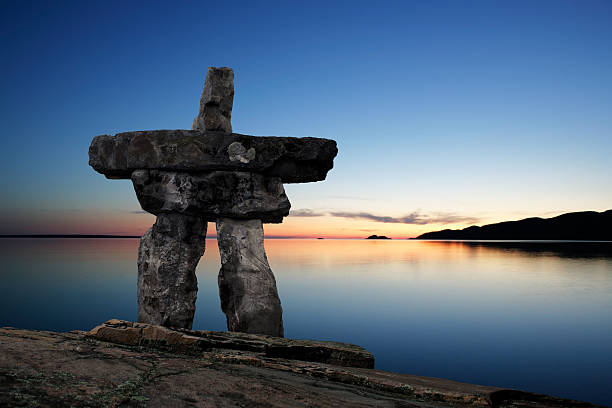What do you see happening in this image? The image showcases a tranquil sunset scene featuring a traditional stone landmark called an Inukshuk, which is constructed by the Inuit people. Situated on a rocky shoreline, the Inukshuk is made of large, flat stones skillfully arranged to resemble a human figure. The deep blue sky, graded with shades of orange and pink near the horizon, creates a vibrant backdrop. Calm waters in the foreground mirror the sky's colors, amplifying the peacefulness of the scene. This serene setting, captured from the side of the Inukshuk, directs the viewer's gaze towards the distant horizon, evoking a sense of depth and expansiveness. The image beautifully captures elements of Inuit culture alongside the natural splendor of the landscape where these landmarks are commonly found. 